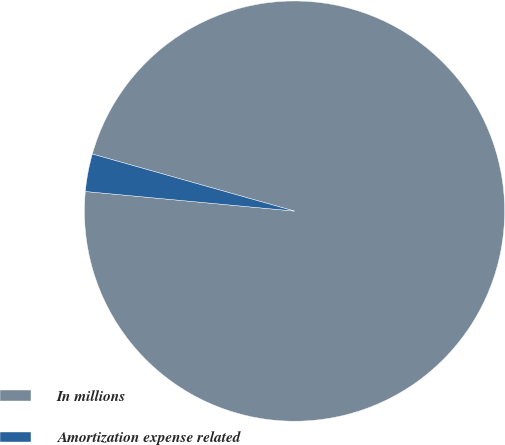<chart> <loc_0><loc_0><loc_500><loc_500><pie_chart><fcel>In millions<fcel>Amortization expense related<nl><fcel>97.11%<fcel>2.89%<nl></chart> 